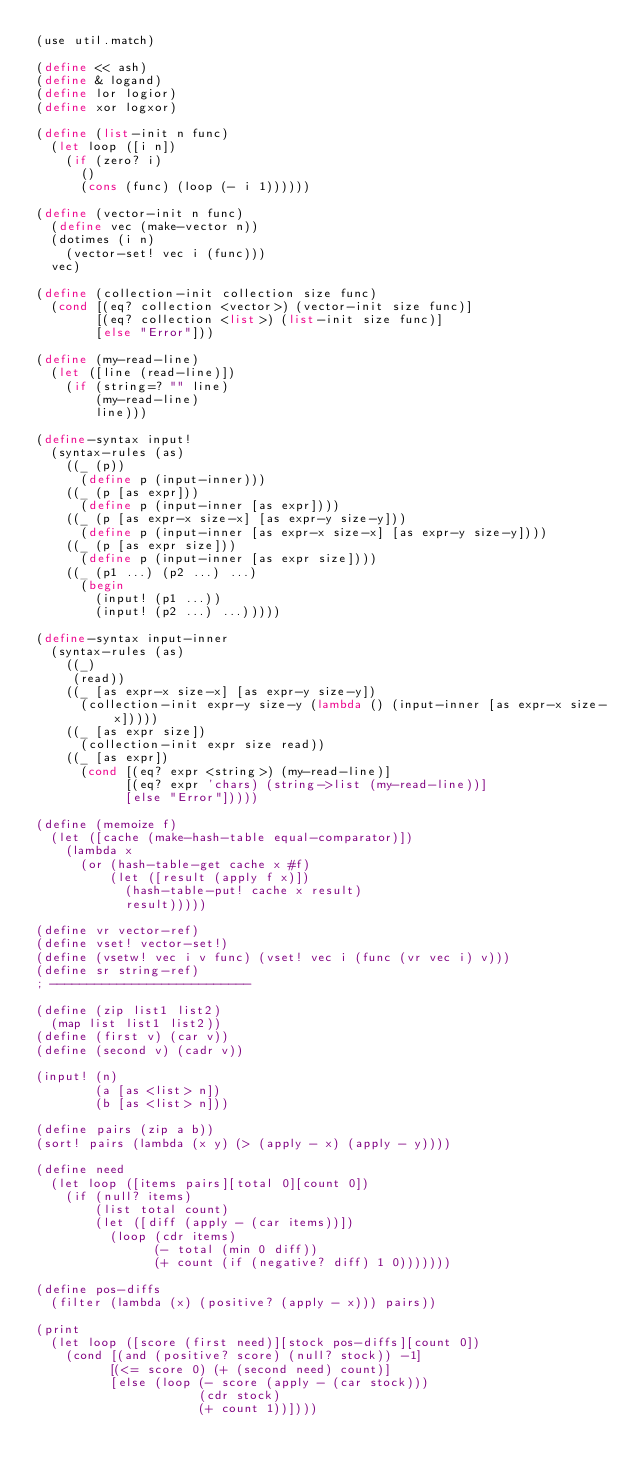<code> <loc_0><loc_0><loc_500><loc_500><_Scheme_>(use util.match)

(define << ash)
(define & logand)
(define lor logior)
(define xor logxor)

(define (list-init n func)
  (let loop ([i n])
    (if (zero? i)
      ()
      (cons (func) (loop (- i 1))))))

(define (vector-init n func)
  (define vec (make-vector n))
  (dotimes (i n)
    (vector-set! vec i (func)))
  vec)

(define (collection-init collection size func)
  (cond [(eq? collection <vector>) (vector-init size func)]
        [(eq? collection <list>) (list-init size func)]
        [else "Error"]))

(define (my-read-line)
  (let ([line (read-line)])
    (if (string=? "" line)
        (my-read-line)
        line)))

(define-syntax input!
  (syntax-rules (as)
    ((_ (p))
      (define p (input-inner)))
    ((_ (p [as expr]))
      (define p (input-inner [as expr])))
    ((_ (p [as expr-x size-x] [as expr-y size-y]))
      (define p (input-inner [as expr-x size-x] [as expr-y size-y])))
    ((_ (p [as expr size]))
      (define p (input-inner [as expr size])))
    ((_ (p1 ...) (p2 ...) ...)
      (begin 
        (input! (p1 ...))
        (input! (p2 ...) ...)))))

(define-syntax input-inner
  (syntax-rules (as)
    ((_)
     (read))
    ((_ [as expr-x size-x] [as expr-y size-y])
      (collection-init expr-y size-y (lambda () (input-inner [as expr-x size-x]))))
    ((_ [as expr size])
      (collection-init expr size read))
    ((_ [as expr])
      (cond [(eq? expr <string>) (my-read-line)]
            [(eq? expr 'chars) (string->list (my-read-line))]
            [else "Error"]))))

(define (memoize f)
  (let ([cache (make-hash-table equal-comparator)])
    (lambda x
      (or (hash-table-get cache x #f)
          (let ([result (apply f x)])
            (hash-table-put! cache x result)
            result)))))

(define vr vector-ref)
(define vset! vector-set!)
(define (vsetw! vec i v func) (vset! vec i (func (vr vec i) v)))
(define sr string-ref)
; ---------------------------

(define (zip list1 list2)
  (map list list1 list2))
(define (first v) (car v))
(define (second v) (cadr v))

(input! (n)
        (a [as <list> n])
        (b [as <list> n]))

(define pairs (zip a b))
(sort! pairs (lambda (x y) (> (apply - x) (apply - y))))

(define need
  (let loop ([items pairs][total 0][count 0])
    (if (null? items)
        (list total count)
        (let ([diff (apply - (car items))])
          (loop (cdr items) 
                (- total (min 0 diff))
                (+ count (if (negative? diff) 1 0)))))))

(define pos-diffs
  (filter (lambda (x) (positive? (apply - x))) pairs))

(print 
  (let loop ([score (first need)][stock pos-diffs][count 0])
    (cond [(and (positive? score) (null? stock)) -1]
          [(<= score 0) (+ (second need) count)]
          [else (loop (- score (apply - (car stock)))
                      (cdr stock)
                      (+ count 1))])))
</code> 